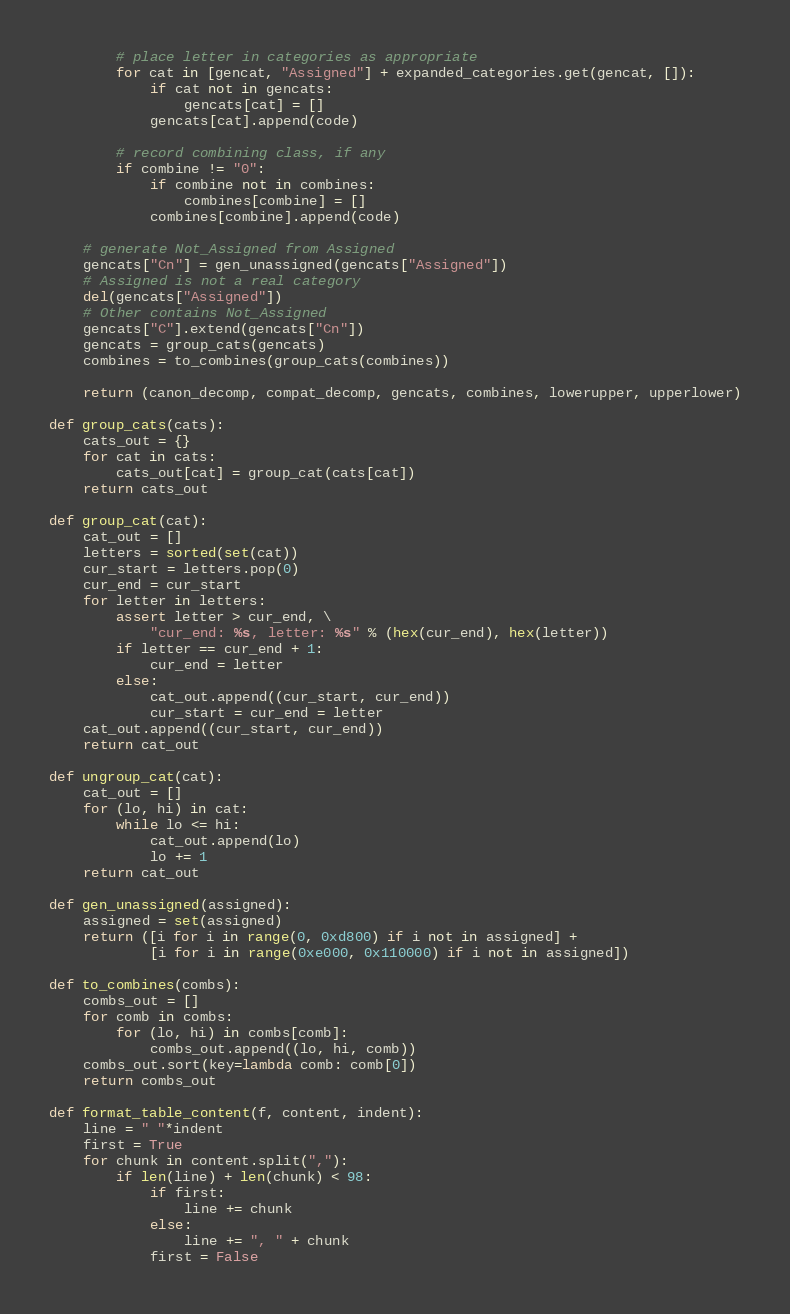Convert code to text. <code><loc_0><loc_0><loc_500><loc_500><_Python_>        # place letter in categories as appropriate
        for cat in [gencat, "Assigned"] + expanded_categories.get(gencat, []):
            if cat not in gencats:
                gencats[cat] = []
            gencats[cat].append(code)

        # record combining class, if any
        if combine != "0":
            if combine not in combines:
                combines[combine] = []
            combines[combine].append(code)

    # generate Not_Assigned from Assigned
    gencats["Cn"] = gen_unassigned(gencats["Assigned"])
    # Assigned is not a real category
    del(gencats["Assigned"])
    # Other contains Not_Assigned
    gencats["C"].extend(gencats["Cn"])
    gencats = group_cats(gencats)
    combines = to_combines(group_cats(combines))

    return (canon_decomp, compat_decomp, gencats, combines, lowerupper, upperlower)

def group_cats(cats):
    cats_out = {}
    for cat in cats:
        cats_out[cat] = group_cat(cats[cat])
    return cats_out

def group_cat(cat):
    cat_out = []
    letters = sorted(set(cat))
    cur_start = letters.pop(0)
    cur_end = cur_start
    for letter in letters:
        assert letter > cur_end, \
            "cur_end: %s, letter: %s" % (hex(cur_end), hex(letter))
        if letter == cur_end + 1:
            cur_end = letter
        else:
            cat_out.append((cur_start, cur_end))
            cur_start = cur_end = letter
    cat_out.append((cur_start, cur_end))
    return cat_out

def ungroup_cat(cat):
    cat_out = []
    for (lo, hi) in cat:
        while lo <= hi:
            cat_out.append(lo)
            lo += 1
    return cat_out

def gen_unassigned(assigned):
    assigned = set(assigned)
    return ([i for i in range(0, 0xd800) if i not in assigned] +
            [i for i in range(0xe000, 0x110000) if i not in assigned])

def to_combines(combs):
    combs_out = []
    for comb in combs:
        for (lo, hi) in combs[comb]:
            combs_out.append((lo, hi, comb))
    combs_out.sort(key=lambda comb: comb[0])
    return combs_out

def format_table_content(f, content, indent):
    line = " "*indent
    first = True
    for chunk in content.split(","):
        if len(line) + len(chunk) < 98:
            if first:
                line += chunk
            else:
                line += ", " + chunk
            first = False</code> 